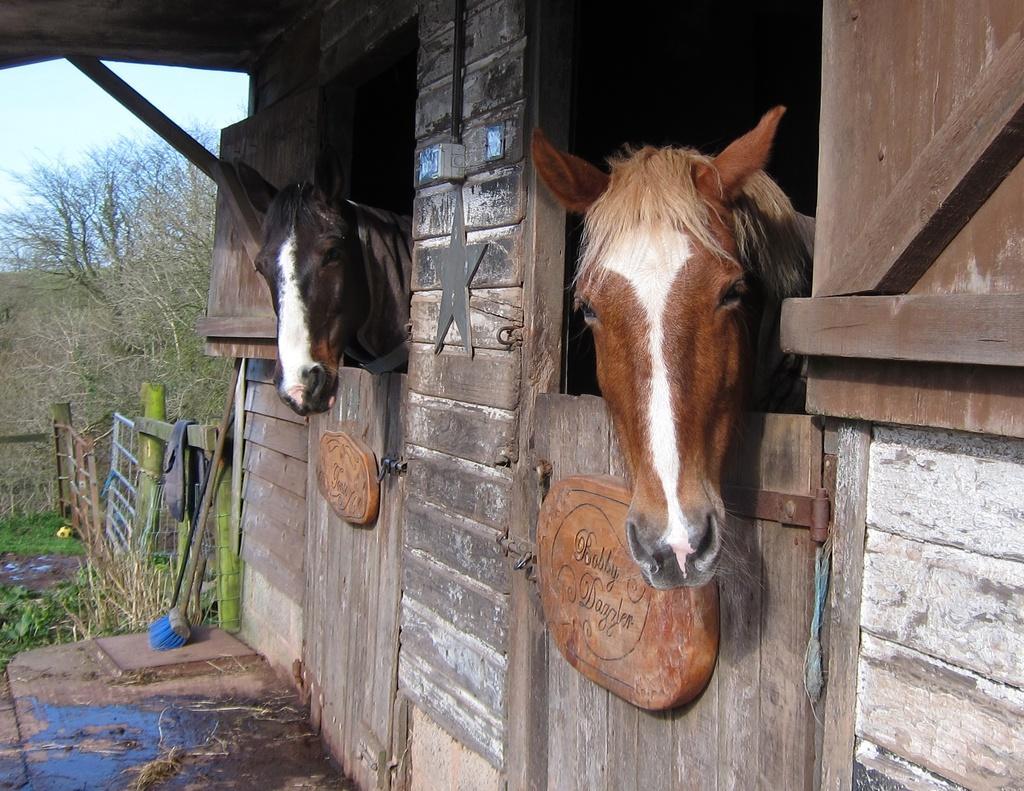Please provide a concise description of this image. On the right, there are two horses in a building which is having wooden doors. Beside this building, there is a fence. In the background, there are trees and there are clouds in the sky. 